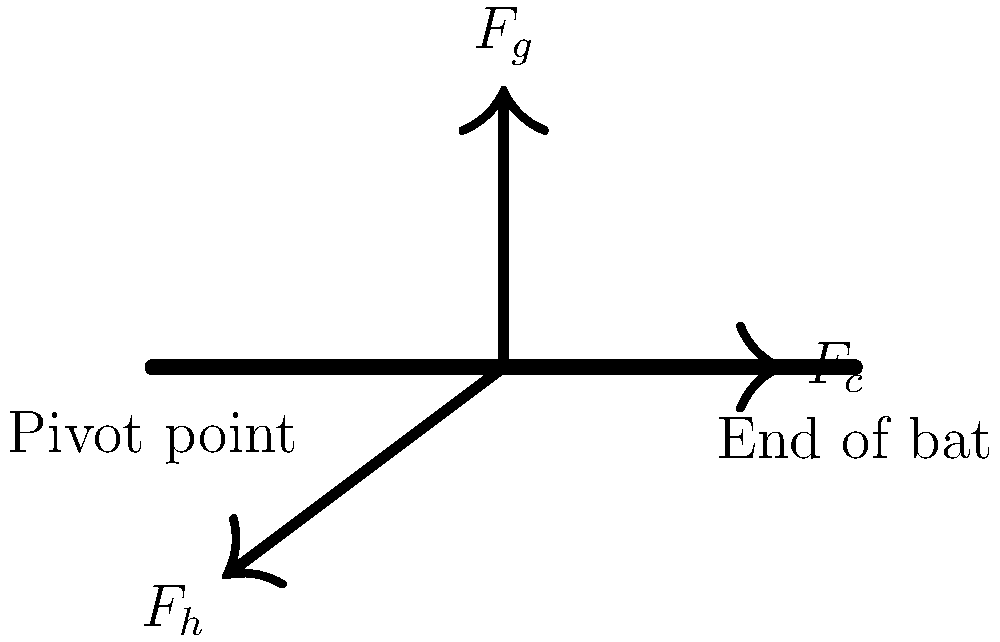As you consider signing your child up for baseball, you're curious about the physics involved in swinging a bat. The diagram shows three forces acting on a baseball bat during a swing: the gravitational force ($F_g$), the centripetal force ($F_c$), and the force applied by the batter's hands ($F_h$). If the bat's mass is 1 kg and it's being swung in a circular path with a radius of 1 m at a constant angular velocity of 10 rad/s, what is the magnitude of the centripetal force ($F_c$) acting on the end of the bat? To solve this problem, we'll use the following steps:

1. Recall the formula for centripetal force:
   $$F_c = m\omega^2r$$
   where:
   $F_c$ = centripetal force
   $m$ = mass of the object
   $\omega$ = angular velocity
   $r$ = radius of circular path

2. We're given:
   $m = 1$ kg
   $\omega = 10$ rad/s
   $r = 1$ m

3. Substitute these values into the formula:
   $$F_c = (1 \text{ kg})(10 \text{ rad/s})^2(1 \text{ m})$$

4. Calculate:
   $$F_c = (1)(100)(1) = 100 \text{ N}$$

5. The units work out to Newtons (N) because:
   $\text{kg} \cdot (\text{rad}/\text{s})^2 \cdot \text{m} = \text{kg} \cdot \text{m}/\text{s}^2 = \text{N}$

Therefore, the magnitude of the centripetal force acting on the end of the bat is 100 N.
Answer: 100 N 